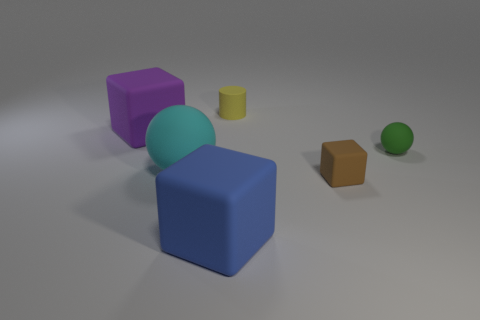What is the tiny thing that is on the left side of the green matte thing and behind the small brown matte object made of?
Ensure brevity in your answer.  Rubber. What number of small things are behind the cube to the right of the small yellow cylinder?
Keep it short and to the point. 2. What is the shape of the cyan object?
Offer a very short reply. Sphere. The blue object that is the same material as the small green thing is what shape?
Your response must be concise. Cube. Does the big thing that is to the right of the big cyan object have the same shape as the yellow thing?
Give a very brief answer. No. What shape is the large object that is to the left of the big sphere?
Your answer should be compact. Cube. What number of matte balls have the same size as the blue block?
Your answer should be compact. 1. What color is the large sphere?
Your response must be concise. Cyan. What is the size of the sphere that is made of the same material as the large cyan thing?
Your response must be concise. Small. What number of objects are large objects left of the large rubber ball or yellow cylinders?
Offer a terse response. 2. 